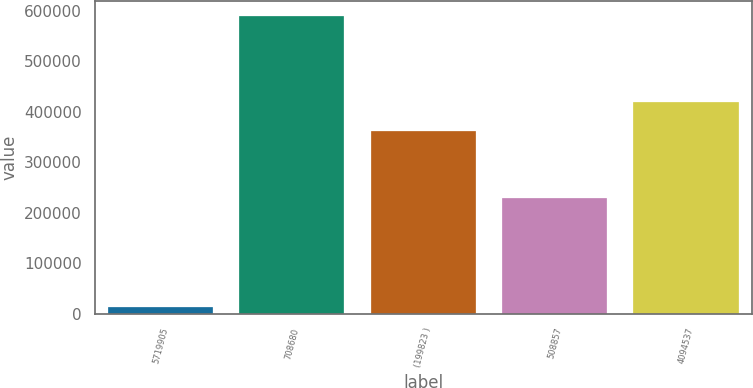<chart> <loc_0><loc_0><loc_500><loc_500><bar_chart><fcel>5719905<fcel>708680<fcel>(199823 )<fcel>508857<fcel>4094537<nl><fcel>13499<fcel>589672<fcel>361105<fcel>228567<fcel>418722<nl></chart> 